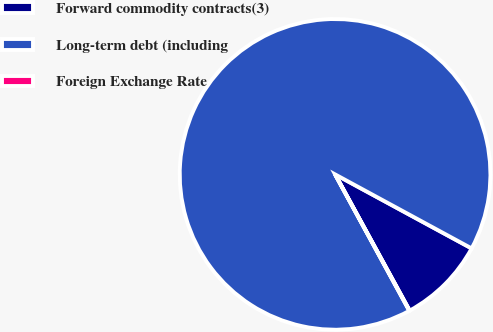<chart> <loc_0><loc_0><loc_500><loc_500><pie_chart><fcel>Forward commodity contracts(3)<fcel>Long-term debt (including<fcel>Foreign Exchange Rate<nl><fcel>9.12%<fcel>90.84%<fcel>0.04%<nl></chart> 